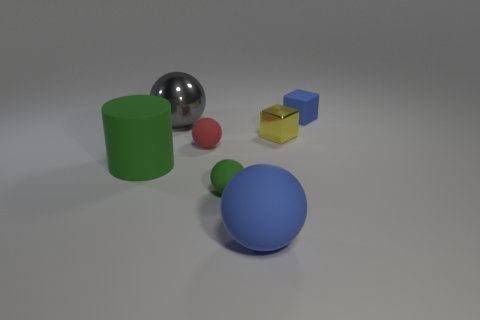Is the number of green objects less than the number of small cyan cylinders?
Provide a short and direct response. No. Are there any blue matte things on the left side of the blue matte thing behind the large blue matte sphere?
Offer a terse response. Yes. Are there any tiny blue objects that are right of the small rubber object right of the shiny thing to the right of the large blue rubber thing?
Offer a very short reply. No. Is the shape of the blue matte thing that is behind the tiny yellow metallic cube the same as the blue thing that is in front of the small blue matte thing?
Keep it short and to the point. No. There is a big object that is the same material as the large blue sphere; what is its color?
Your response must be concise. Green. Are there fewer big green rubber objects behind the rubber block than cylinders?
Your answer should be very brief. Yes. What is the size of the object in front of the green thing that is to the right of the tiny rubber ball that is behind the green ball?
Give a very brief answer. Large. Do the small cube left of the rubber cube and the big gray thing have the same material?
Offer a terse response. Yes. Are there any other things that have the same shape as the big green object?
Make the answer very short. No. How many objects are either small yellow shiny objects or cylinders?
Your answer should be compact. 2. 